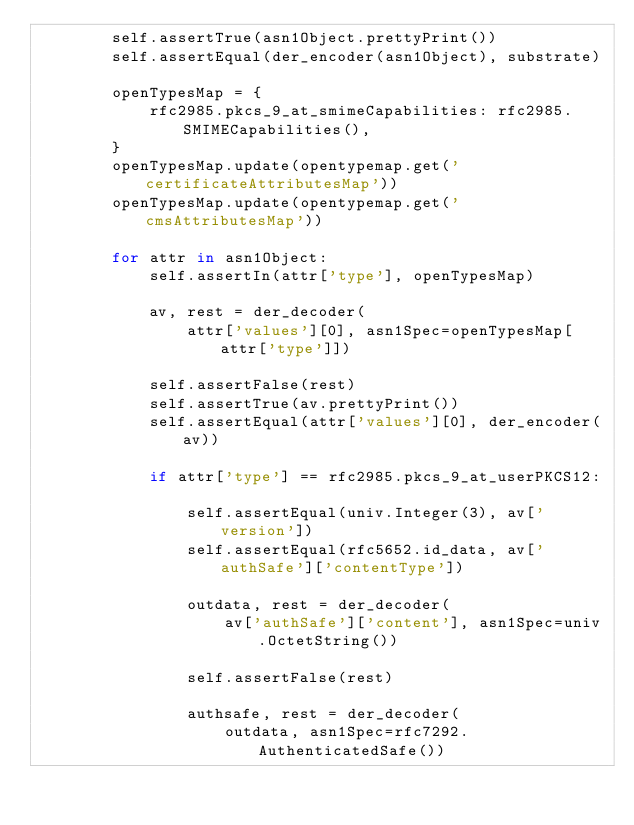<code> <loc_0><loc_0><loc_500><loc_500><_Python_>        self.assertTrue(asn1Object.prettyPrint())
        self.assertEqual(der_encoder(asn1Object), substrate)

        openTypesMap = {
            rfc2985.pkcs_9_at_smimeCapabilities: rfc2985.SMIMECapabilities(),
        }
        openTypesMap.update(opentypemap.get('certificateAttributesMap'))
        openTypesMap.update(opentypemap.get('cmsAttributesMap'))

        for attr in asn1Object:
            self.assertIn(attr['type'], openTypesMap)

            av, rest = der_decoder(
                attr['values'][0], asn1Spec=openTypesMap[attr['type']])

            self.assertFalse(rest)
            self.assertTrue(av.prettyPrint())
            self.assertEqual(attr['values'][0], der_encoder(av))

            if attr['type'] == rfc2985.pkcs_9_at_userPKCS12:

                self.assertEqual(univ.Integer(3), av['version'])
                self.assertEqual(rfc5652.id_data, av['authSafe']['contentType'])

                outdata, rest = der_decoder(
                    av['authSafe']['content'], asn1Spec=univ.OctetString())

                self.assertFalse(rest)

                authsafe, rest = der_decoder(
                    outdata, asn1Spec=rfc7292.AuthenticatedSafe())
</code> 